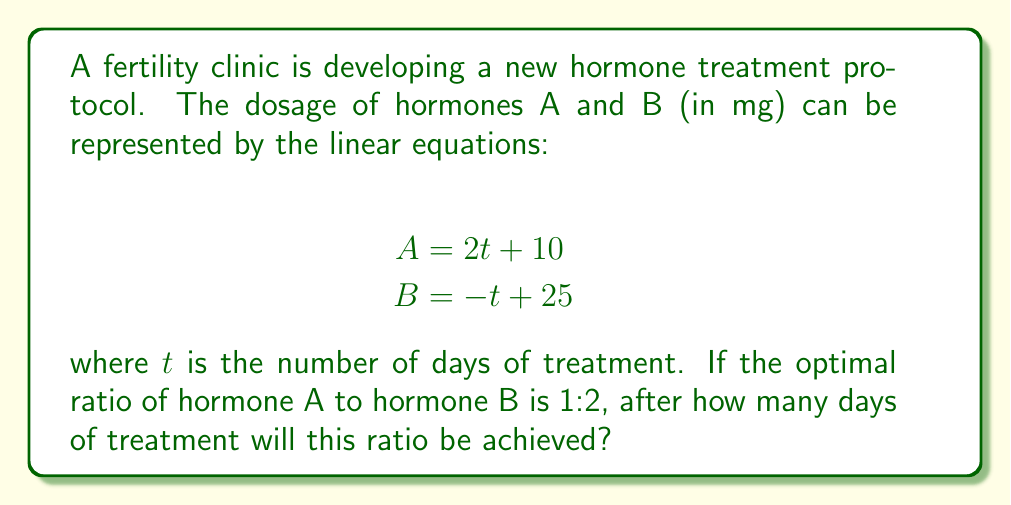Can you solve this math problem? To solve this problem, we'll follow these steps:

1) The optimal ratio of A:B is 1:2, which means we need to find when A = 1/2 B.

2) Let's set up an equation representing this relationship:
   $A = \frac{1}{2}B$

3) Now, substitute the given equations for A and B:
   $2t + 10 = \frac{1}{2}(-t + 25)$

4) Multiply both sides by 2 to eliminate the fraction:
   $4t + 20 = -t + 25$

5) Add $t$ to both sides:
   $5t + 20 = 25$

6) Subtract 20 from both sides:
   $5t = 5$

7) Divide both sides by 5:
   $t = 1$

8) Check the result:
   For $t = 1$:
   $A = 2(1) + 10 = 12$
   $B = -(1) + 25 = 24$
   
   Indeed, $12 = \frac{1}{2}(24)$, confirming our solution.
Answer: $1$ day 